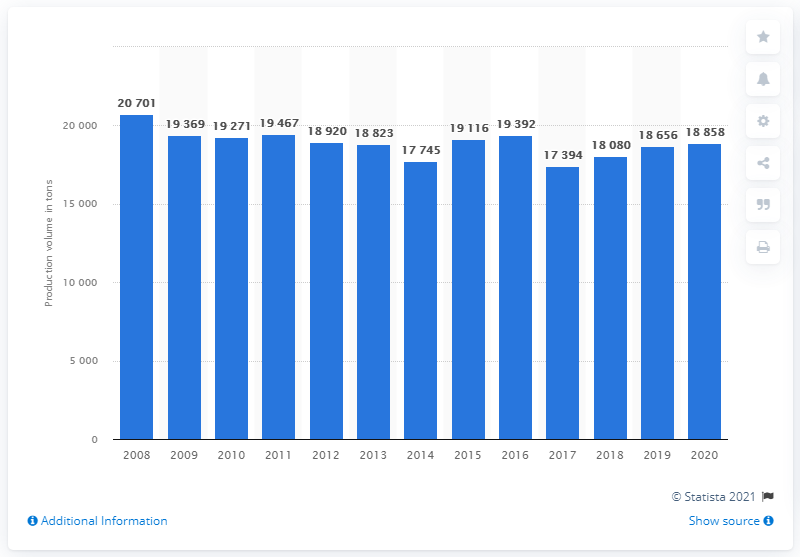Identify some key points in this picture. In 2017, the lowest volume of Roquefort cheese produced was 17,394 units. In 2008, the production volume of Roquefort was approximately 207,010 units. 